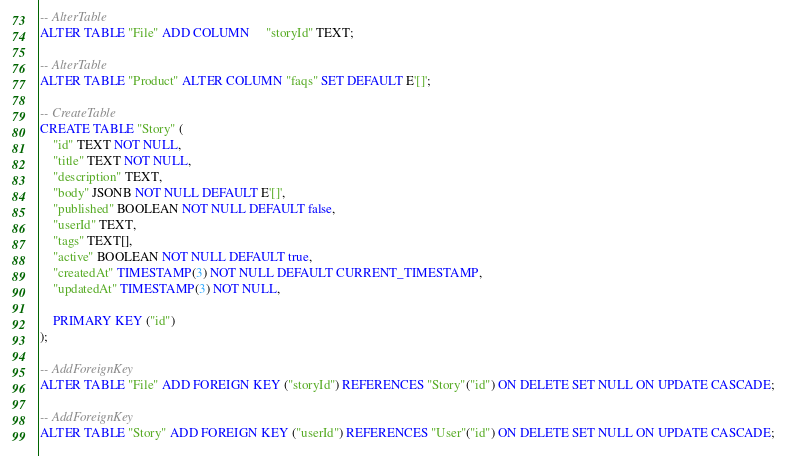Convert code to text. <code><loc_0><loc_0><loc_500><loc_500><_SQL_>-- AlterTable
ALTER TABLE "File" ADD COLUMN     "storyId" TEXT;

-- AlterTable
ALTER TABLE "Product" ALTER COLUMN "faqs" SET DEFAULT E'[]';

-- CreateTable
CREATE TABLE "Story" (
    "id" TEXT NOT NULL,
    "title" TEXT NOT NULL,
    "description" TEXT,
    "body" JSONB NOT NULL DEFAULT E'[]',
    "published" BOOLEAN NOT NULL DEFAULT false,
    "userId" TEXT,
    "tags" TEXT[],
    "active" BOOLEAN NOT NULL DEFAULT true,
    "createdAt" TIMESTAMP(3) NOT NULL DEFAULT CURRENT_TIMESTAMP,
    "updatedAt" TIMESTAMP(3) NOT NULL,

    PRIMARY KEY ("id")
);

-- AddForeignKey
ALTER TABLE "File" ADD FOREIGN KEY ("storyId") REFERENCES "Story"("id") ON DELETE SET NULL ON UPDATE CASCADE;

-- AddForeignKey
ALTER TABLE "Story" ADD FOREIGN KEY ("userId") REFERENCES "User"("id") ON DELETE SET NULL ON UPDATE CASCADE;
</code> 